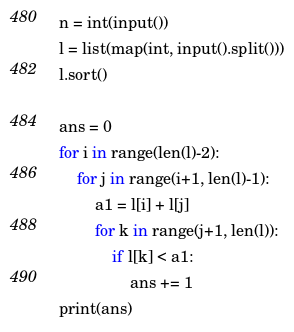Convert code to text. <code><loc_0><loc_0><loc_500><loc_500><_Python_>n = int(input())
l = list(map(int, input().split()))
l.sort()

ans = 0
for i in range(len(l)-2):
    for j in range(i+1, len(l)-1):
        a1 = l[i] + l[j]
        for k in range(j+1, len(l)):
            if l[k] < a1:
                ans += 1
print(ans)</code> 